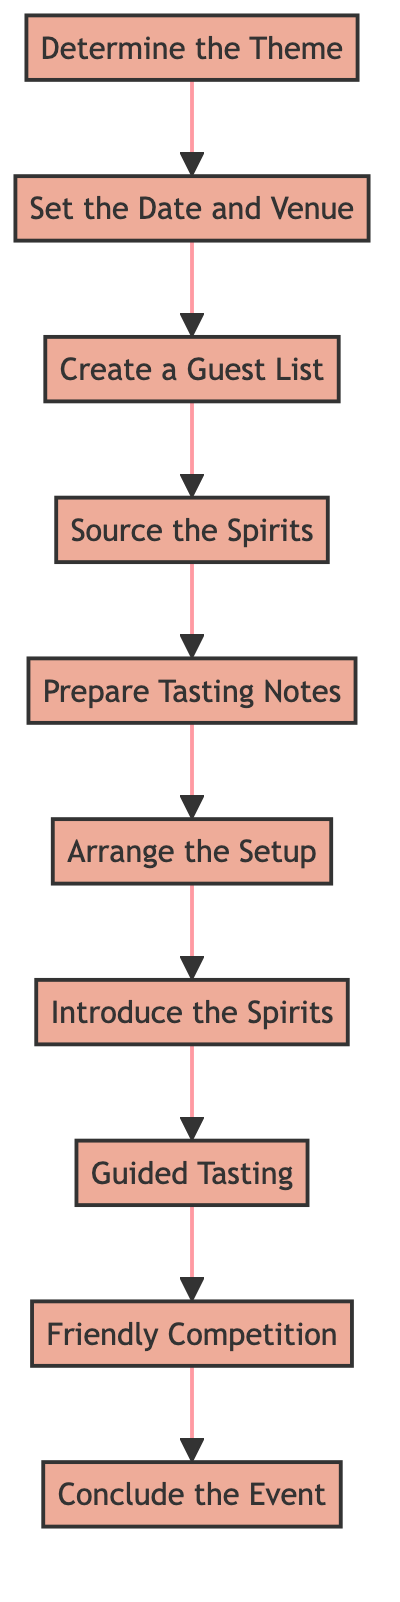What is the first step in organizing a spirits tasting event? The first step, as shown in the diagram, is to "Determine the Theme". This is the starting point of the process and sets the direction for the entire event.
Answer: Determine the Theme How many total steps are there in the process? By counting the nodes in the diagram, there are ten steps in total: from "Determine the Theme" to "Conclude the Event".
Answer: Ten What step follows 'Prepare Tasting Notes'? According to the flow, after "Prepare Tasting Notes", the next step is "Arrange the Setup". This shows the sequential progression of the event planning.
Answer: Arrange the Setup What is the last step in the process? The last step indicated in the diagram is "Conclude the Event", which wraps up the entirety of the tasting experience.
Answer: Conclude the Event What is the relationship between 'Guided Tasting' and 'Introduce the Spirits'? In the diagram, "Introduce the Spirits" directly precedes "Guided Tasting", indicating that an introduction to the spirits must happen before guests engage in the guided tasting process.
Answer: Introduce the Spirits precedes Guided Tasting What steps involve guest interaction? The steps involving guest interaction include "Guided Tasting" and "Friendly Competition". These stages engage guests in discussion, comparison, and tasting activities.
Answer: Guided Tasting, Friendly Competition Which step requires sourcing spirits? "Source the Spirits" is the designated step where spirits are acquired for the tasting. This is critical for ensuring a quality tasting experience.
Answer: Source the Spirits What happens right after 'Set the Date and Venue'? Following "Set the Date and Venue", the next step is "Create a Guest List". This indicates the importance of securing attendees after finalizing logistics.
Answer: Create a Guest List What type of experience does 'Friendly Competition' provide? "Friendly Competition" offers a fun and interactive element by challenging guests during a blind tasting round, enhancing engagement and excitement.
Answer: Interactive experience 